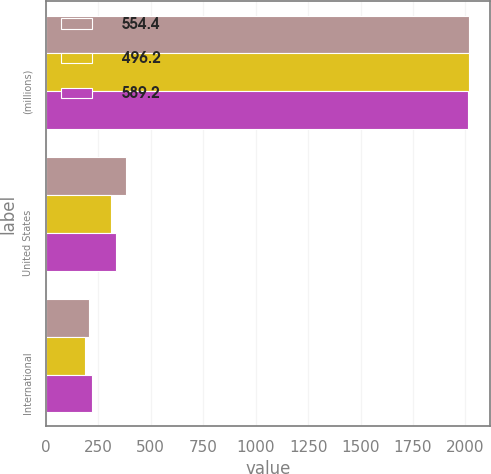<chart> <loc_0><loc_0><loc_500><loc_500><stacked_bar_chart><ecel><fcel>(millions)<fcel>United States<fcel>International<nl><fcel>554.4<fcel>2016<fcel>383.3<fcel>205.9<nl><fcel>496.2<fcel>2015<fcel>308.3<fcel>187.9<nl><fcel>589.2<fcel>2014<fcel>333.2<fcel>221.2<nl></chart> 